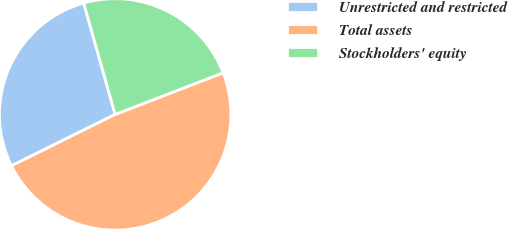<chart> <loc_0><loc_0><loc_500><loc_500><pie_chart><fcel>Unrestricted and restricted<fcel>Total assets<fcel>Stockholders' equity<nl><fcel>27.94%<fcel>48.54%<fcel>23.52%<nl></chart> 